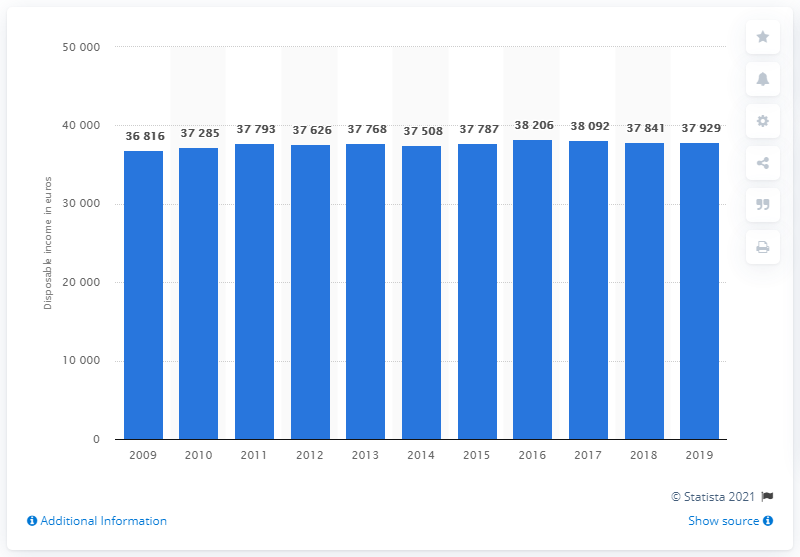Indicate a few pertinent items in this graphic. In 2011, the median disposable income of households in Finland remained stable. 